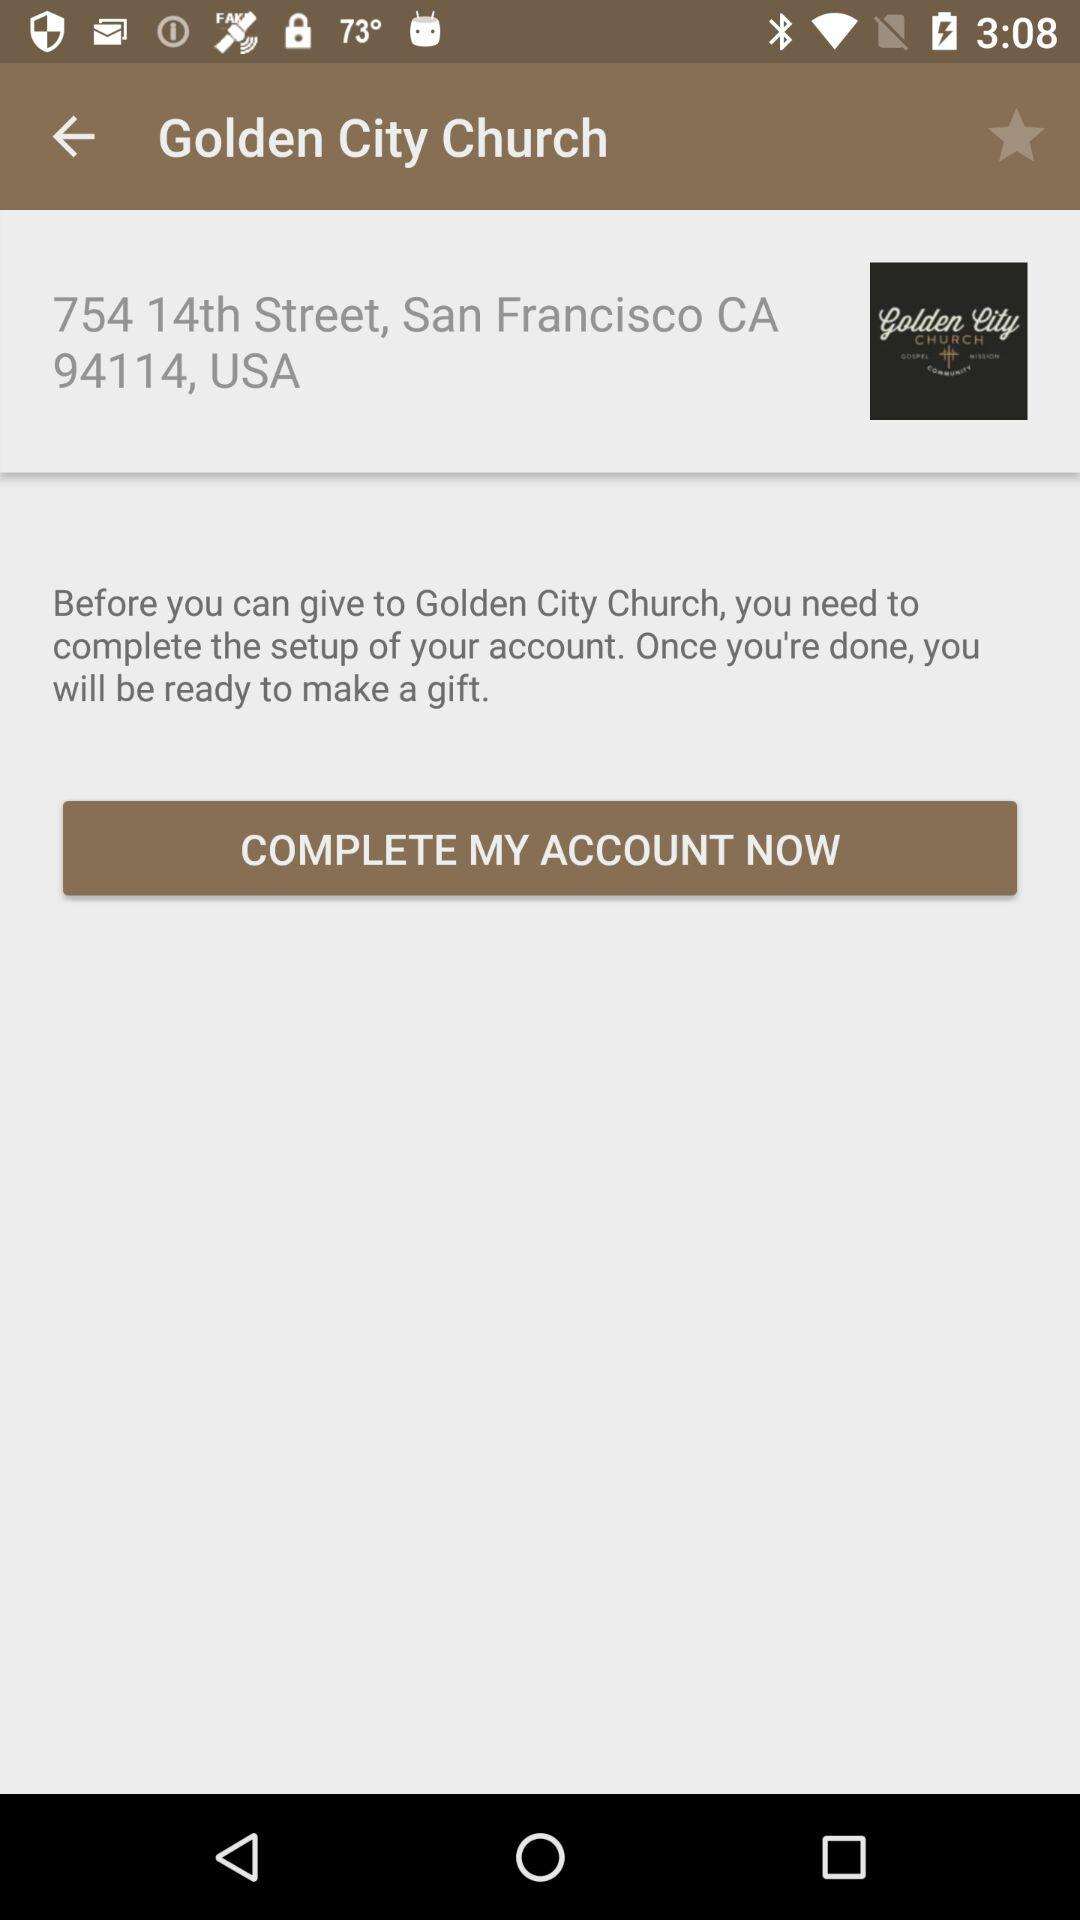What is the mentioned address? The mentioned address is 754 14th Street, San Francisco, CA 94114, USA. 